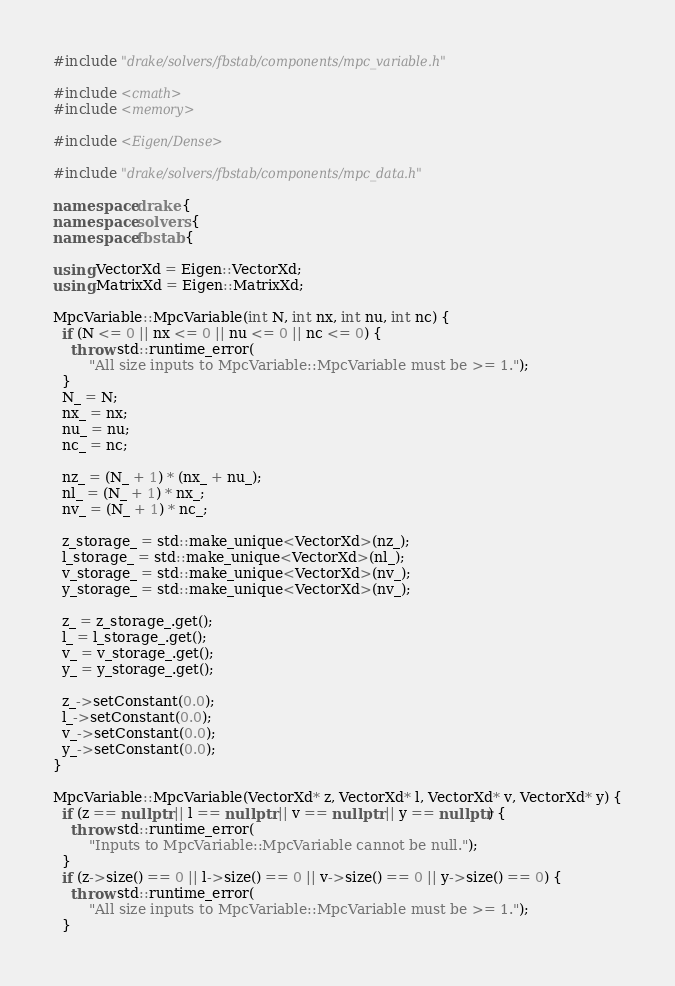<code> <loc_0><loc_0><loc_500><loc_500><_C++_>#include "drake/solvers/fbstab/components/mpc_variable.h"

#include <cmath>
#include <memory>

#include <Eigen/Dense>

#include "drake/solvers/fbstab/components/mpc_data.h"

namespace drake {
namespace solvers {
namespace fbstab {

using VectorXd = Eigen::VectorXd;
using MatrixXd = Eigen::MatrixXd;

MpcVariable::MpcVariable(int N, int nx, int nu, int nc) {
  if (N <= 0 || nx <= 0 || nu <= 0 || nc <= 0) {
    throw std::runtime_error(
        "All size inputs to MpcVariable::MpcVariable must be >= 1.");
  }
  N_ = N;
  nx_ = nx;
  nu_ = nu;
  nc_ = nc;

  nz_ = (N_ + 1) * (nx_ + nu_);
  nl_ = (N_ + 1) * nx_;
  nv_ = (N_ + 1) * nc_;

  z_storage_ = std::make_unique<VectorXd>(nz_);
  l_storage_ = std::make_unique<VectorXd>(nl_);
  v_storage_ = std::make_unique<VectorXd>(nv_);
  y_storage_ = std::make_unique<VectorXd>(nv_);

  z_ = z_storage_.get();
  l_ = l_storage_.get();
  v_ = v_storage_.get();
  y_ = y_storage_.get();

  z_->setConstant(0.0);
  l_->setConstant(0.0);
  v_->setConstant(0.0);
  y_->setConstant(0.0);
}

MpcVariable::MpcVariable(VectorXd* z, VectorXd* l, VectorXd* v, VectorXd* y) {
  if (z == nullptr || l == nullptr || v == nullptr || y == nullptr) {
    throw std::runtime_error(
        "Inputs to MpcVariable::MpcVariable cannot be null.");
  }
  if (z->size() == 0 || l->size() == 0 || v->size() == 0 || y->size() == 0) {
    throw std::runtime_error(
        "All size inputs to MpcVariable::MpcVariable must be >= 1.");
  }</code> 